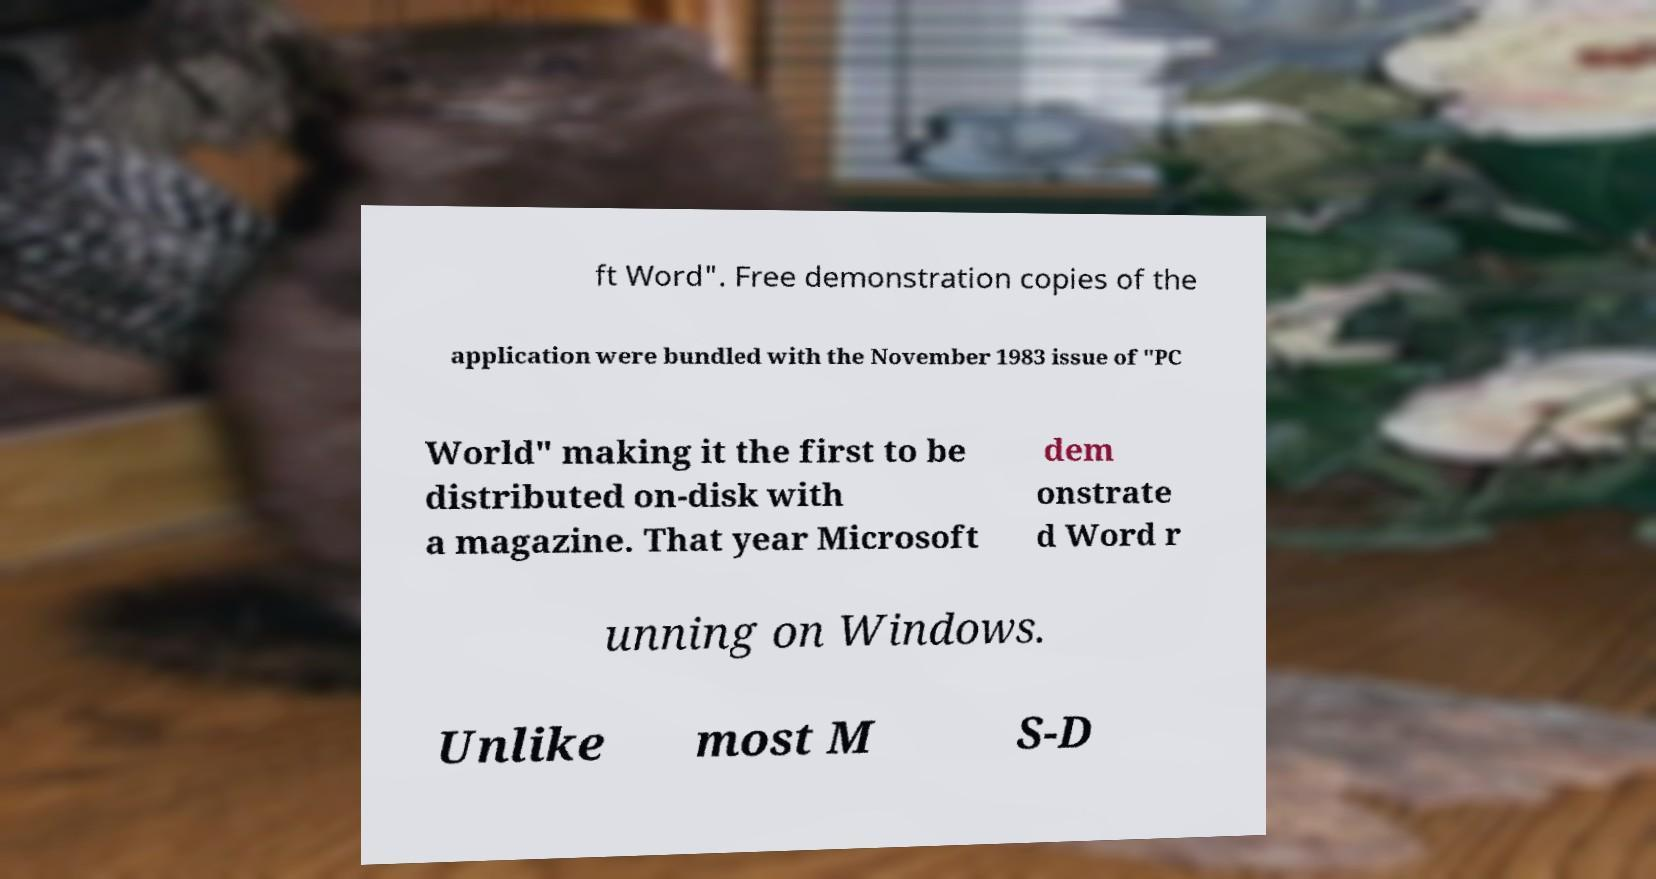Please read and relay the text visible in this image. What does it say? ft Word". Free demonstration copies of the application were bundled with the November 1983 issue of "PC World" making it the first to be distributed on-disk with a magazine. That year Microsoft dem onstrate d Word r unning on Windows. Unlike most M S-D 